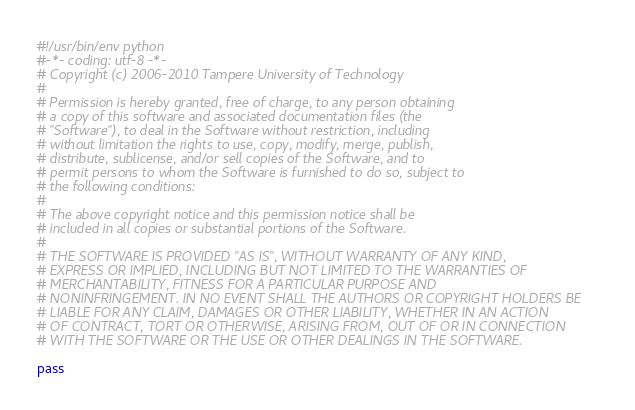Convert code to text. <code><loc_0><loc_0><loc_500><loc_500><_Python_>#!/usr/bin/env python
#-*- coding: utf-8 -*-
# Copyright (c) 2006-2010 Tampere University of Technology
# 
# Permission is hereby granted, free of charge, to any person obtaining
# a copy of this software and associated documentation files (the
# "Software"), to deal in the Software without restriction, including
# without limitation the rights to use, copy, modify, merge, publish,
# distribute, sublicense, and/or sell copies of the Software, and to
# permit persons to whom the Software is furnished to do so, subject to
# the following conditions:
# 
# The above copyright notice and this permission notice shall be
# included in all copies or substantial portions of the Software.
# 
# THE SOFTWARE IS PROVIDED "AS IS", WITHOUT WARRANTY OF ANY KIND,
# EXPRESS OR IMPLIED, INCLUDING BUT NOT LIMITED TO THE WARRANTIES OF
# MERCHANTABILITY, FITNESS FOR A PARTICULAR PURPOSE AND
# NONINFRINGEMENT. IN NO EVENT SHALL THE AUTHORS OR COPYRIGHT HOLDERS BE
# LIABLE FOR ANY CLAIM, DAMAGES OR OTHER LIABILITY, WHETHER IN AN ACTION
# OF CONTRACT, TORT OR OTHERWISE, ARISING FROM, OUT OF OR IN CONNECTION
# WITH THE SOFTWARE OR THE USE OR OTHER DEALINGS IN THE SOFTWARE.

pass
</code> 